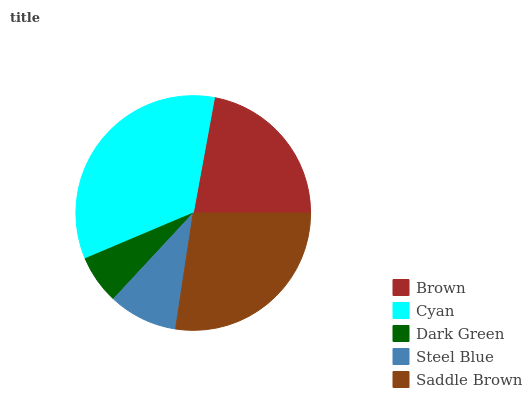Is Dark Green the minimum?
Answer yes or no. Yes. Is Cyan the maximum?
Answer yes or no. Yes. Is Cyan the minimum?
Answer yes or no. No. Is Dark Green the maximum?
Answer yes or no. No. Is Cyan greater than Dark Green?
Answer yes or no. Yes. Is Dark Green less than Cyan?
Answer yes or no. Yes. Is Dark Green greater than Cyan?
Answer yes or no. No. Is Cyan less than Dark Green?
Answer yes or no. No. Is Brown the high median?
Answer yes or no. Yes. Is Brown the low median?
Answer yes or no. Yes. Is Cyan the high median?
Answer yes or no. No. Is Steel Blue the low median?
Answer yes or no. No. 